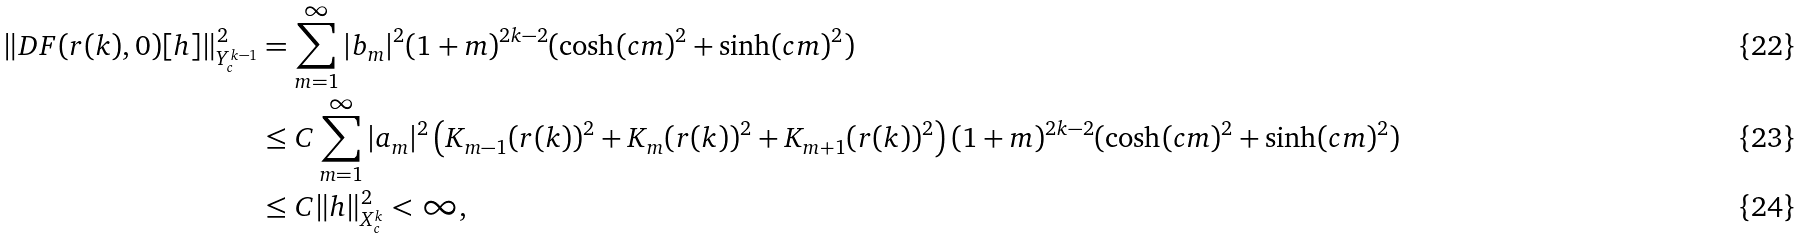Convert formula to latex. <formula><loc_0><loc_0><loc_500><loc_500>\| D F ( r ( k ) , 0 ) [ h ] \| _ { Y ^ { k - 1 } _ { c } } ^ { 2 } & = \sum _ { m = 1 } ^ { \infty } | b _ { m } | ^ { 2 } ( 1 + m ) ^ { 2 k - 2 } ( \cosh ( c m ) ^ { 2 } + \sinh ( c m ) ^ { 2 } ) \\ & \leq C \sum _ { m = 1 } ^ { \infty } | a _ { m } | ^ { 2 } \left ( K _ { m - 1 } ( r ( k ) ) ^ { 2 } + K _ { m } ( r ( k ) ) ^ { 2 } + K _ { m + 1 } ( r ( k ) ) ^ { 2 } \right ) ( 1 + m ) ^ { 2 k - 2 } ( \cosh ( c m ) ^ { 2 } + \sinh ( c m ) ^ { 2 } ) \\ & \leq C \| h \| _ { X ^ { k } _ { c } } ^ { 2 } < \infty ,</formula> 